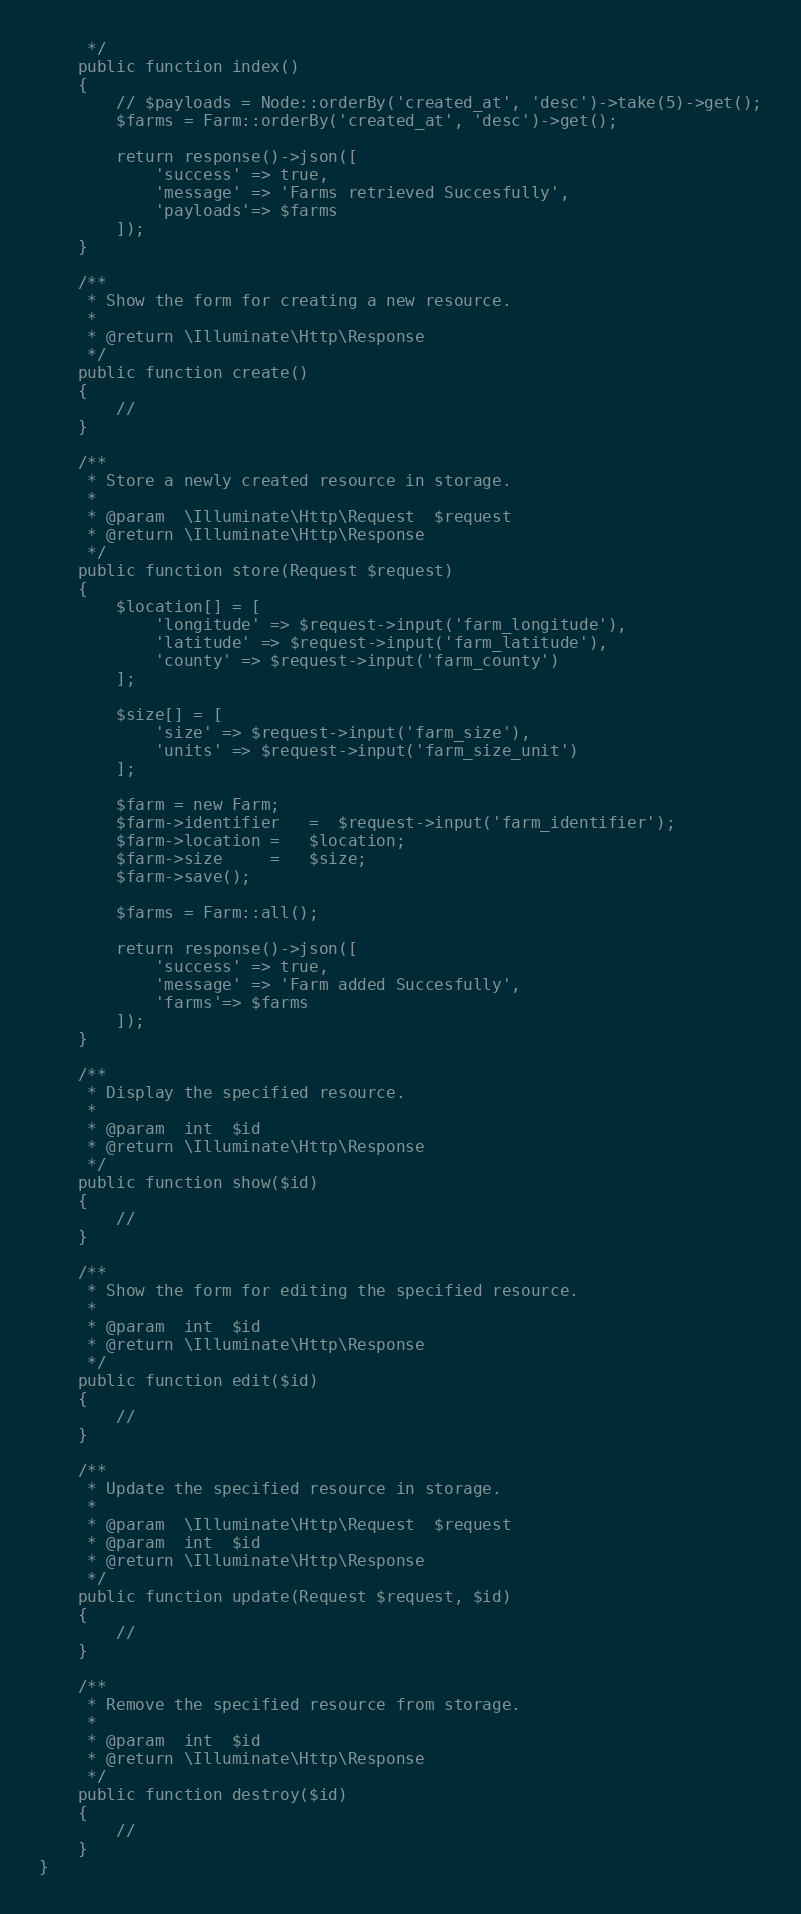<code> <loc_0><loc_0><loc_500><loc_500><_PHP_>     */
    public function index()
    {
        // $payloads = Node::orderBy('created_at', 'desc')->take(5)->get();
        $farms = Farm::orderBy('created_at', 'desc')->get();
        
        return response()->json([
            'success' => true,
            'message' => 'Farms retrieved Succesfully',
            'payloads'=> $farms
        ]);
    }

    /**
     * Show the form for creating a new resource.
     *
     * @return \Illuminate\Http\Response
     */
    public function create()
    {
        // 
    }

    /**
     * Store a newly created resource in storage.
     *
     * @param  \Illuminate\Http\Request  $request
     * @return \Illuminate\Http\Response
     */
    public function store(Request $request)
    {
        $location[] = [
            'longitude' => $request->input('farm_longitude'),
            'latitude' => $request->input('farm_latitude'),
            'county' => $request->input('farm_county')
        ];

        $size[] = [
            'size' => $request->input('farm_size'),
            'units' => $request->input('farm_size_unit')
        ];
        
        $farm = new Farm;
        $farm->identifier   =  $request->input('farm_identifier'); 
        $farm->location =   $location;
        $farm->size     =   $size;
        $farm->save();

        $farms = Farm::all();

        return response()->json([
            'success' => true,
            'message' => 'Farm added Succesfully',
            'farms'=> $farms
        ]);
    }

    /**
     * Display the specified resource.
     *
     * @param  int  $id
     * @return \Illuminate\Http\Response
     */
    public function show($id)
    {
        //
    }

    /**
     * Show the form for editing the specified resource.
     *
     * @param  int  $id
     * @return \Illuminate\Http\Response
     */
    public function edit($id)
    {
        //
    }

    /**
     * Update the specified resource in storage.
     *
     * @param  \Illuminate\Http\Request  $request
     * @param  int  $id
     * @return \Illuminate\Http\Response
     */
    public function update(Request $request, $id)
    {
        //
    }

    /**
     * Remove the specified resource from storage.
     *
     * @param  int  $id
     * @return \Illuminate\Http\Response
     */
    public function destroy($id)
    {
        //
    }
}
</code> 